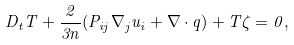Convert formula to latex. <formula><loc_0><loc_0><loc_500><loc_500>D _ { t } T + \frac { 2 } { 3 n } ( P _ { i j } \nabla _ { j } u _ { i } + \nabla \cdot { q } ) + T \zeta = 0 ,</formula> 